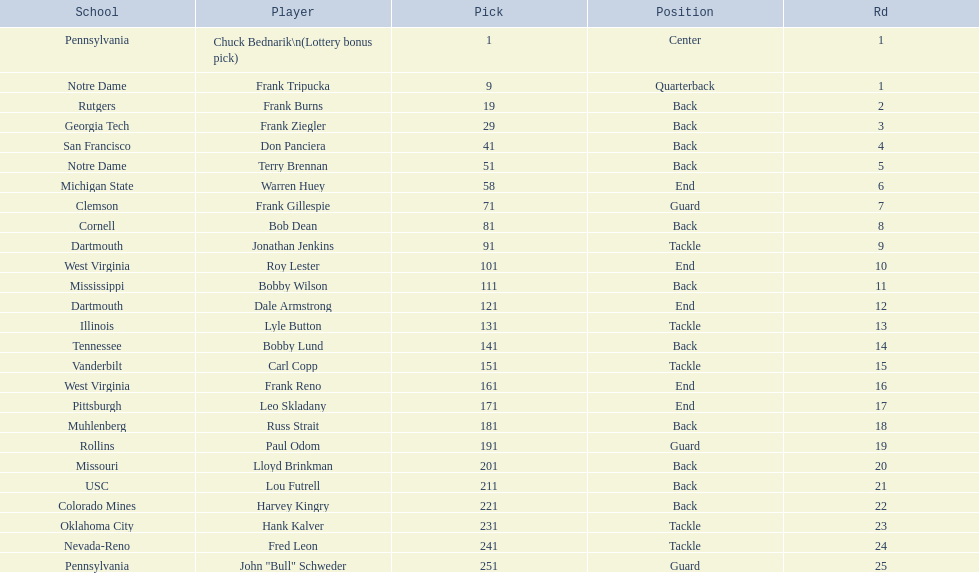Who shares an equivalent position with frank gillespie? Paul Odom, John "Bull" Schweder. 